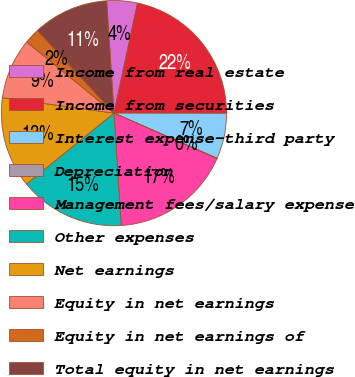Convert chart. <chart><loc_0><loc_0><loc_500><loc_500><pie_chart><fcel>Income from real estate<fcel>Income from securities<fcel>Interest expense-third party<fcel>Depreciation<fcel>Management fees/salary expense<fcel>Other expenses<fcel>Net earnings<fcel>Equity in net earnings<fcel>Equity in net earnings of<fcel>Total equity in net earnings<nl><fcel>4.38%<fcel>21.67%<fcel>6.54%<fcel>0.06%<fcel>17.35%<fcel>15.19%<fcel>13.02%<fcel>8.7%<fcel>2.22%<fcel>10.86%<nl></chart> 